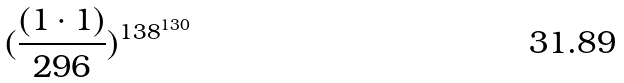Convert formula to latex. <formula><loc_0><loc_0><loc_500><loc_500>( \frac { ( 1 \cdot 1 ) } { 2 9 6 } ) ^ { 1 3 8 ^ { 1 3 0 } }</formula> 